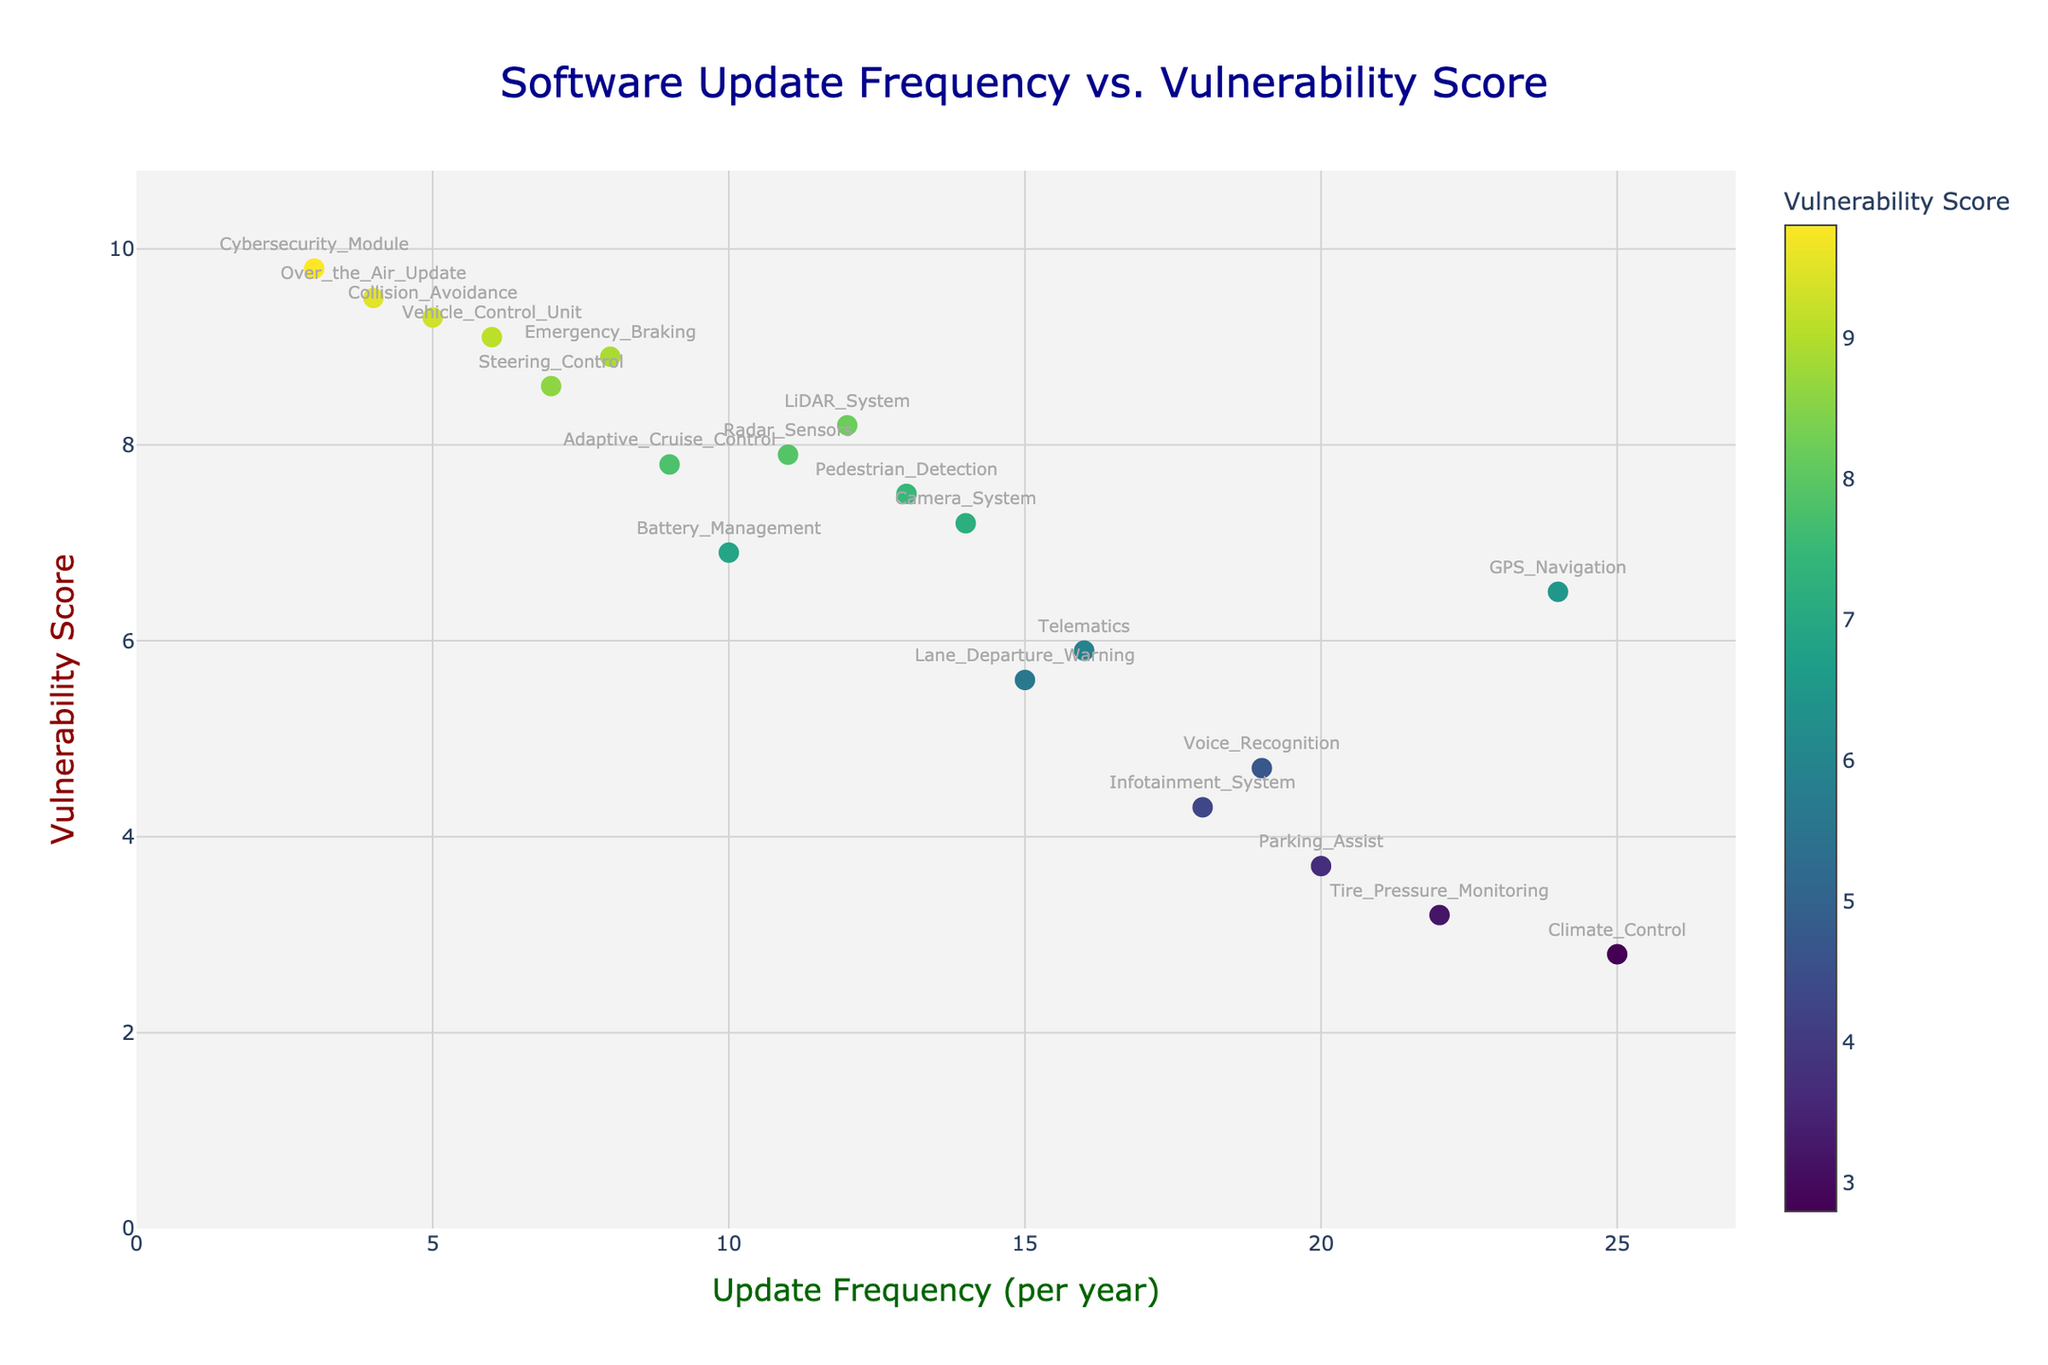what is the title of the plot? The title is displayed prominently at the top of the plot. It reads "Software Update Frequency vs. Vulnerability Score".
Answer: Software Update Frequency vs. Vulnerability Score What does the x-axis title represent? The x-axis title is located beneath the horizontal axis. It represents the frequency of software updates per year.
Answer: Update Frequency (per year) Which module has the highest vulnerability score? By looking at the y-values, the module with the highest point is the 'Cybersecurity Module' with a score of 9.8.
Answer: Cybersecurity_Module How often is the 'LiDAR System' updated per year? The 'LiDAR System' label can be found along the x-axis, aligned with a value of 12 on the update frequency axis.
Answer: 12 Which module with the lowest vulnerability score and what is it? Checking the lowest y-value, the 'Climate_Control’ module has a score of 2.8.
Answer: Climate_Control, 2.8 What's the average vulnerability score of modules updated more than 10 times per year? Identify modules with an update frequency > 10: LiDAR_System (8.2), GPS_Navigation (6.5), Infotainment_System (4.3), Lane_Departure_Warning (5.6), Parking_Assist (3.7), Camera_System (7.2), Telematics (5.9), Tire_Pressure_Monitoring (3.2), Climate_Control (2.8), Voice_Recognition (4.7), Pedestrian_Detection (7.5). Calculating the average: (8.2+6.5+4.3+5.6+3.7+7.2+5.9+3.2+2.8+4.7+7.5)/11 = 5.35.
Answer: 5.35 Which module has a higher vulnerability score: 'Over the Air Update' or 'Emergency Braking'? The y-axis position of 'Over the Air Update' is 9.5, while 'Emergency Braking' is 8.9.
Answer: Over the Air Update What is the difference in vulnerability scores between 'Vehicle Control Unit' and 'Collision Avoidance'? Locate the y-values for both modules: 'Vehicle Control Unit' is 9.1, 'Collision Avoidance' is 9.3. Calculate the difference: 9.3 - 9.1 = 0.2.
Answer: 0.2 Which module is updated less frequently: ‘Steering Control’ or 'Radar Sensors'? Compare the x-axis values: ‘Steering Control' is at 7, and ’Radar Sensors’ is at 11. ‘Steering Control’ is updated less frequently.
Answer: Steering Control How many modules are updated 15 times per year or more? Count the modules with an update frequency ≥ 15: Lane_Departure_Warning (15), GPS_Navigation (24), Infotainment_System (18), Parking_Assist (20), Tire_Pressure_Monitoring (22), Voice_Recognition (19), Climate_Control (25).
Answer: 7 